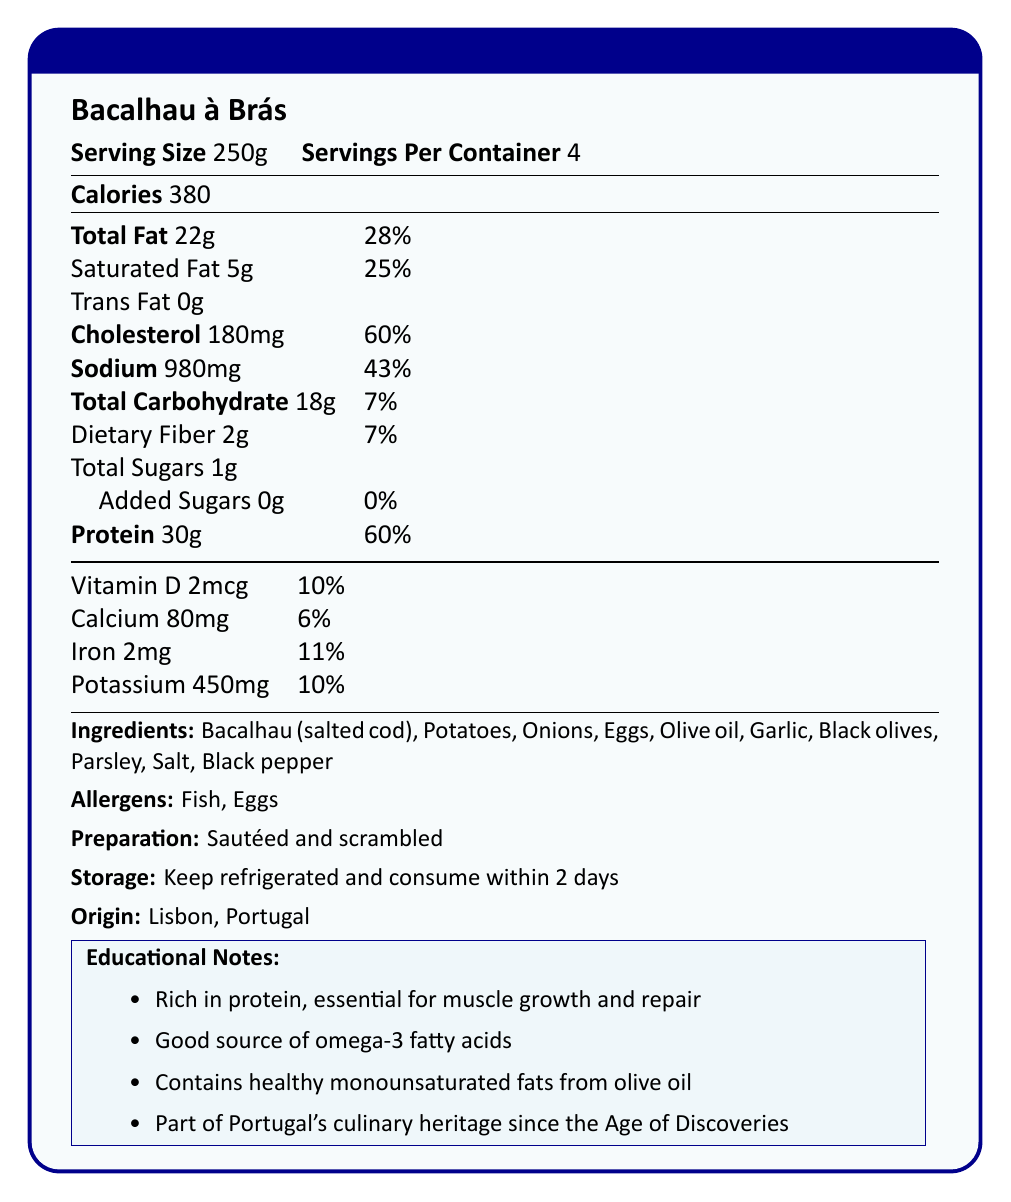what is the serving size for Bacalhau à Brás? The document specifies that the serving size for Bacalhau à Brás is 250g.
Answer: 250g how many calories are there per serving? The document states that there are 380 calories per serving.
Answer: 380 how much total fat is in a serving, and what is its percentage daily value? The document indicates that a serving contains 22g of total fat, which is 28% of the daily value.
Answer: 22g, 28% list three key ingredients in Bacalhau à Brás. The ingredients list in the document starts with Bacalhau (salted cod), Potatoes, and Onions.
Answer: Bacalhau (salted cod), Potatoes, Onions which two allergens are present in Bacalhau à Brás? The allergens listed in the document are Fish and Eggs.
Answer: Fish, Eggs what is the amount of protein per serving, and what percentage of the daily value does it represent? The document indicates that a serving contains 30g of protein, which is 60% of the daily value.
Answer: 30g, 60% what is the preparation method for Bacalhau à Brás? A. Boiled B. Baked C. Sautéed and scrambled D. Grilled The document states that Bacalhau à Brás is prepared by being sautéed and scrambled.
Answer: C. Sautéed and scrambled which of the following is a nutritional benefit of Bacalhau à Brás mentioned in the educational notes? A. High in carbohydrates B. Good source of vitamin C C. Contains healthy monounsaturated fats from olive oil D. Low in sodium One of the educational notes mentions that Bacalhau à Brás contains healthy monounsaturated fats from olive oil.
Answer: C. Contains healthy monounsaturated fats from olive oil is Bacalhau à Brás part of Portugal's culinary heritage? The document mentions that Bacalhau à Brás is part of Portugal's rich culinary heritage, dating back to the Age of Discoveries.
Answer: Yes summarize the nutritional information and key details provided for Bacalhau à Brás. The document provides detailed nutritional information, including macronutrient breakdown and daily values, ingredients, allergens, and preparation and storage instructions. It also highlights educational notes and cultural significance.
Answer: Bacalhau à Brás has 380 calories per serving with 22g of total fat (28% DV), 5g of saturated fat (25% DV), 0g trans fat, 180mg cholesterol (60% DV), 980mg sodium (43% DV), 18g total carbohydrates (7% DV) including 2g dietary fiber (7% DV) and 1g sugars, 30g protein (60% DV), 2mcg Vitamin D (10% DV), 80mg calcium (6% DV), 2mg iron (11% DV), and 450mg potassium (10% DV). Ingredients include Bacalhau (salted cod), Potatoes, Onions, Eggs, Olive oil, Garlic, Black olives, Parsley, Salt, and Black pepper. It contains allergens Fish and Eggs and is prepared by being sautéed and scrambled. It should be consumed within 2 days if refrigerated. The educational notes highlight its protein content, omega-3 fatty acids, and healthy fats from olive oil, emphasizing its cultural significance. how many servings are there per container of Bacalhau à Brás? The document mentions that there are 4 servings per container.
Answer: 4 what is the source of potassium in Bacalhau à Brás? The document provides the amount and daily value of potassium but does not specify the source.
Answer: Not enough information what are the meal suggestions for Bacalhau à Brás? The document suggests serving Bacalhau à Brás with a simple green salad, pairing it with vinho verde, and accompanying it with broa.
Answer: Serve with a simple green salad, Pair with vinho verde (a young Portuguese white wine), Accompany with broa (traditional Portuguese cornbread) 